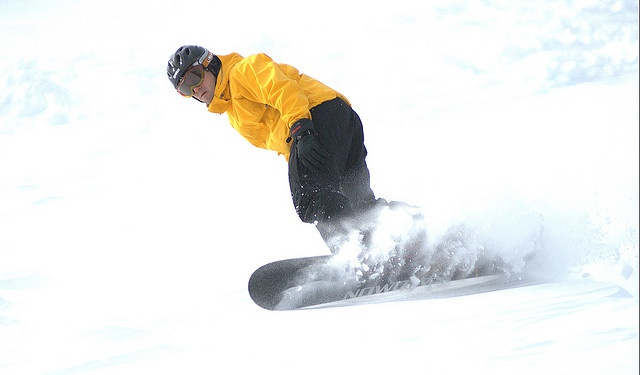Describe the objects in this image and their specific colors. I can see people in white, black, orange, gray, and gold tones and snowboard in white, lightgray, darkgray, and gray tones in this image. 